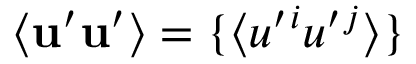Convert formula to latex. <formula><loc_0><loc_0><loc_500><loc_500>\langle { { u } ^ { \prime } { u } ^ { \prime } } \rangle = \{ \langle { u ^ { \prime ^ { i } u ^ { \prime ^ { j } } \rangle \}</formula> 